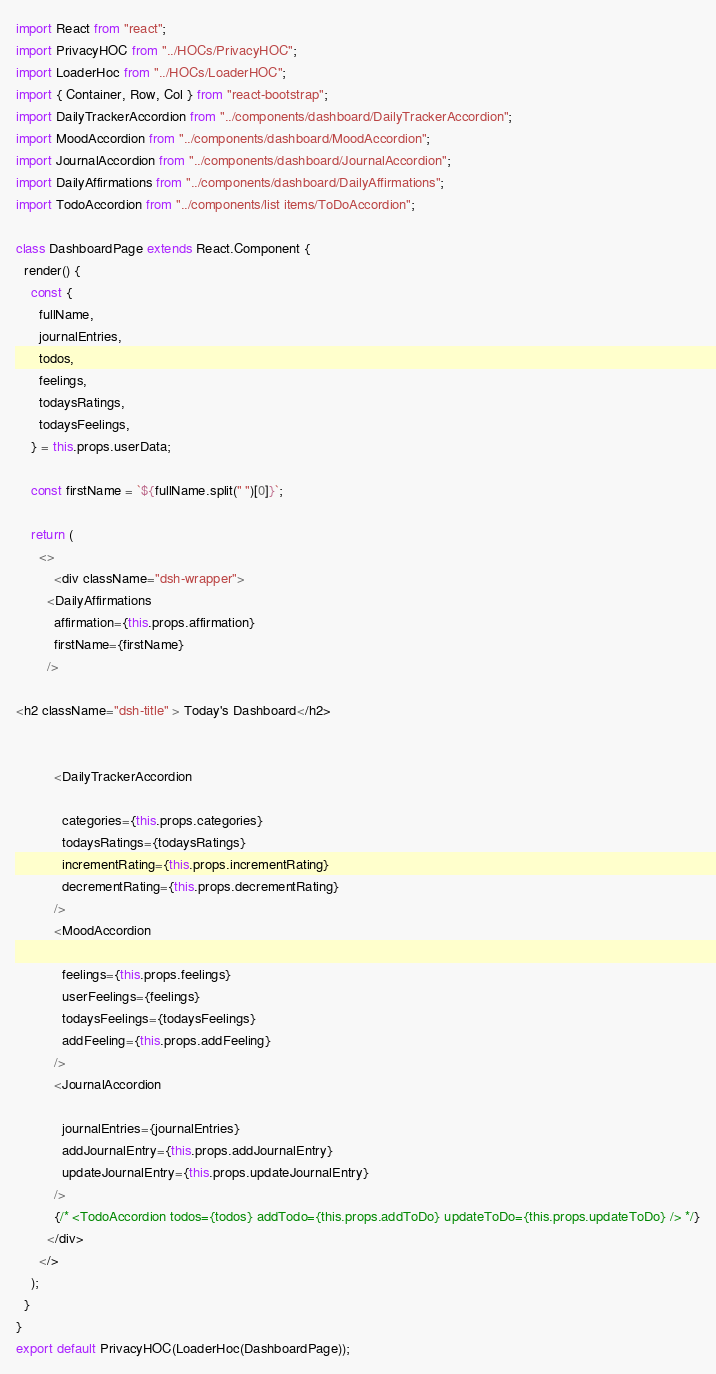<code> <loc_0><loc_0><loc_500><loc_500><_JavaScript_>import React from "react";
import PrivacyHOC from "../HOCs/PrivacyHOC";
import LoaderHoc from "../HOCs/LoaderHOC";
import { Container, Row, Col } from "react-bootstrap";
import DailyTrackerAccordion from "../components/dashboard/DailyTrackerAccordion";
import MoodAccordion from "../components/dashboard/MoodAccordion";
import JournalAccordion from "../components/dashboard/JournalAccordion";
import DailyAffirmations from "../components/dashboard/DailyAffirmations";
import TodoAccordion from "../components/list items/ToDoAccordion";

class DashboardPage extends React.Component {
  render() {
    const {
      fullName,
      journalEntries,
      todos,
      feelings,
      todaysRatings,
      todaysFeelings,
    } = this.props.userData;

    const firstName = `${fullName.split(" ")[0]}`;
 
    return (
      <>
          <div className="dsh-wrapper">
        <DailyAffirmations
          affirmation={this.props.affirmation}
          firstName={firstName}
        />

<h2 className="dsh-title" > Today's Dashboard</h2>


          <DailyTrackerAccordion
        
            categories={this.props.categories}
            todaysRatings={todaysRatings}
            incrementRating={this.props.incrementRating}
            decrementRating={this.props.decrementRating}
          />
          <MoodAccordion
        
            feelings={this.props.feelings}
            userFeelings={feelings}
            todaysFeelings={todaysFeelings}
            addFeeling={this.props.addFeeling}
          />
          <JournalAccordion
        
            journalEntries={journalEntries}
            addJournalEntry={this.props.addJournalEntry}
            updateJournalEntry={this.props.updateJournalEntry}
          />
          {/* <TodoAccordion todos={todos} addTodo={this.props.addToDo} updateToDo={this.props.updateToDo} /> */}
        </div>
      </>
    );
  }
}
export default PrivacyHOC(LoaderHoc(DashboardPage));
</code> 